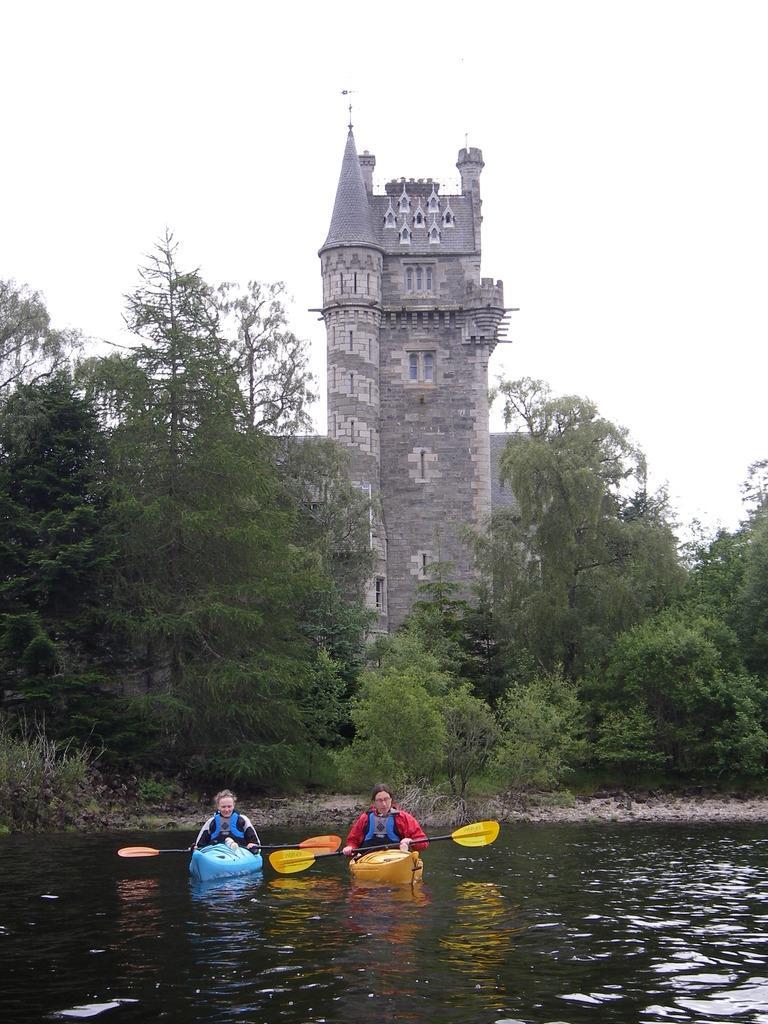Describe this image in one or two sentences. In this image there are two persons floating in an individual boats on the river. At the center of the image there is a building and trees. In the background there is a sky. 